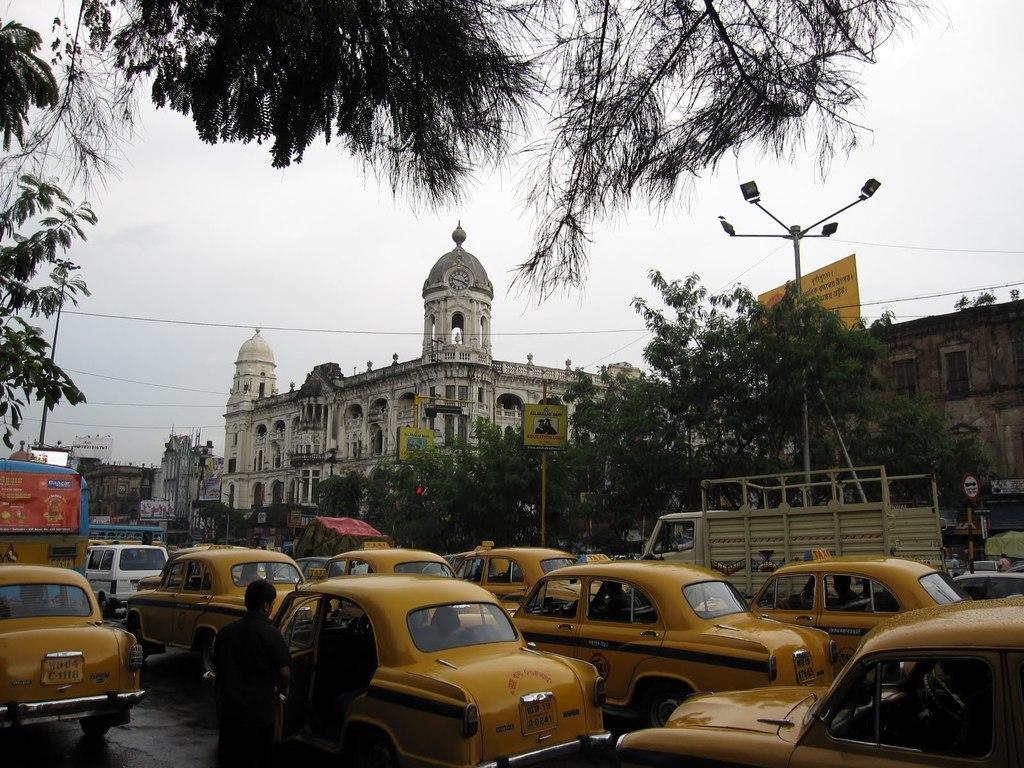Please provide a concise description of this image. In this picture there are many yellow color taxis on the road. Behind there is a white old building with dome and some trees. 